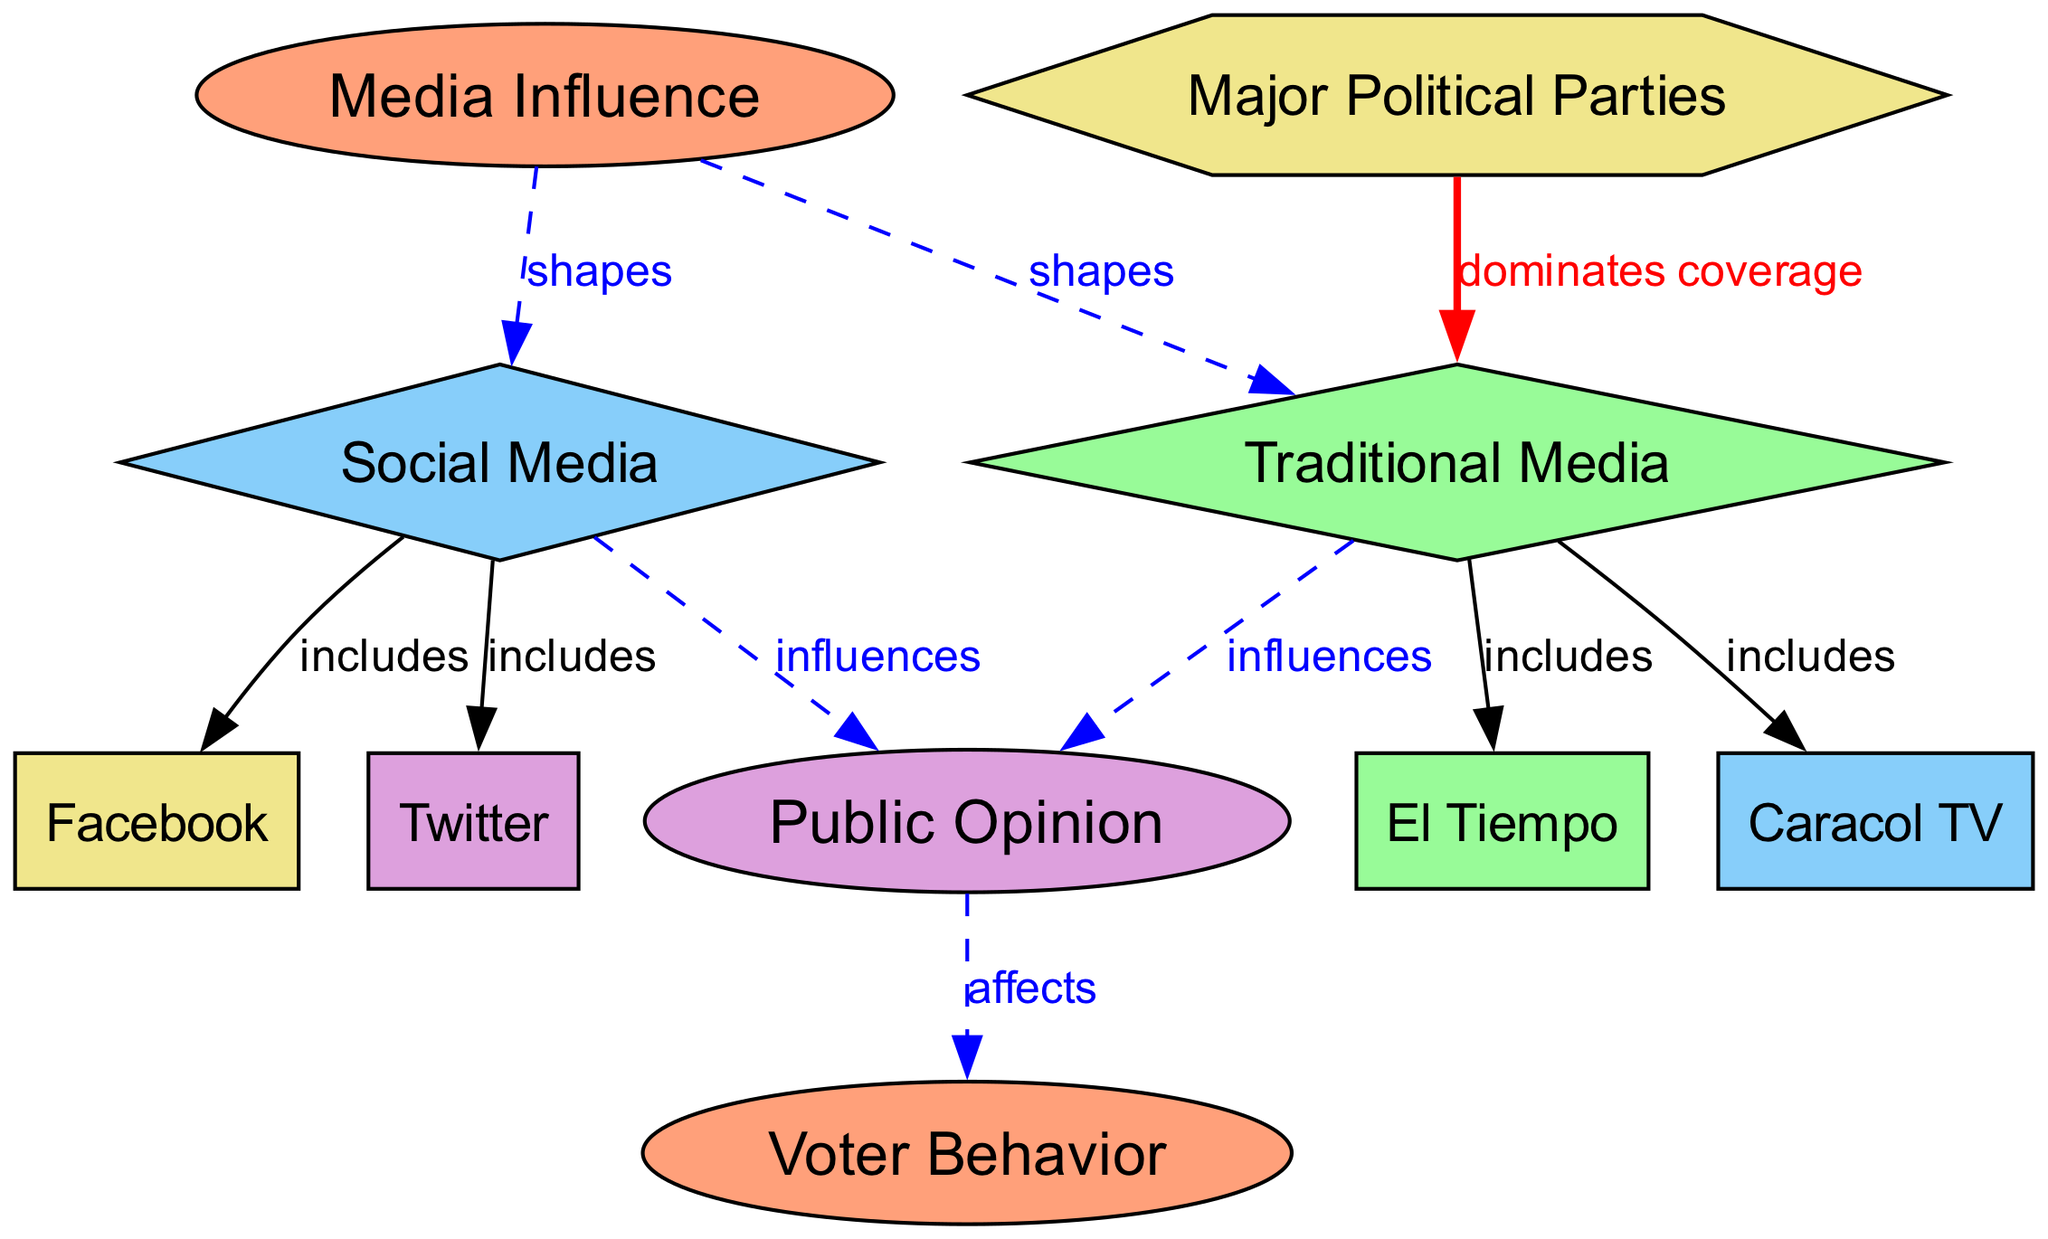What are the two types of media mentioned? The diagram lists "Traditional Media" and "Social Media" as the two categories under the node "Media Influence."
Answer: Traditional Media, Social Media How many nodes are there in the diagram? By counting all unique identifiers in the "nodes" section, I find that there are ten individual nodes.
Answer: 10 Which node includes "El Tiempo"? "El Tiempo" is part of the "Traditional Media" node, which states it as one of its included elements.
Answer: Traditional Media What relationship do "Major Political Parties" and "Traditional Media" have? The diagram shows that "Major Political Parties" dominate the coverage of "Traditional Media," indicating a strong influence on what is reported.
Answer: Dominates coverage What does "Social Media" influence? The "Social Media" node is connected to "Public Opinion," indicating that it plays a significant role in shaping the public's perspectives and attitudes.
Answer: Public Opinion Which node is affected by "Public Opinion"? "Voter Behavior" is shown as being directly affected by "Public Opinion" in the diagram, indicating a connection between public perception and voting choices.
Answer: Voter Behavior How many edges are associated with the node "Media Influence"? Counting the directed edges (connections) from the "Media Influence" node, there are four outgoing edges to "Traditional Media," "Social Media," "Public Opinion," and "Voter Behavior."
Answer: 4 What is the nature of the influence that "Traditional Media" has? The influence of "Traditional Media" is described as affecting "Public Opinion," meaning that the information presented in traditional formats shapes how the public thinks.
Answer: Influences Which social media platforms are included under "Social Media"? The platforms mentioned are "Twitter" and "Facebook," which are both listed as included elements under the "Social Media" node.
Answer: Twitter, Facebook 